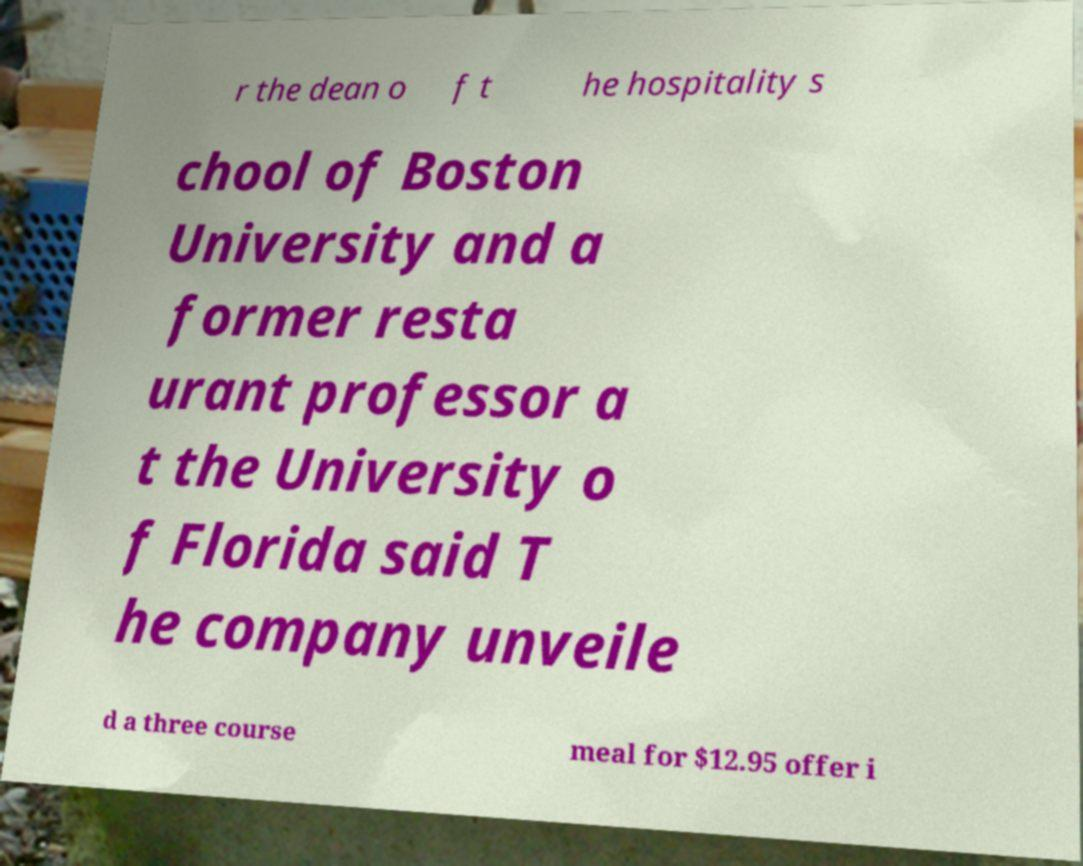There's text embedded in this image that I need extracted. Can you transcribe it verbatim? r the dean o f t he hospitality s chool of Boston University and a former resta urant professor a t the University o f Florida said T he company unveile d a three course meal for $12.95 offer i 